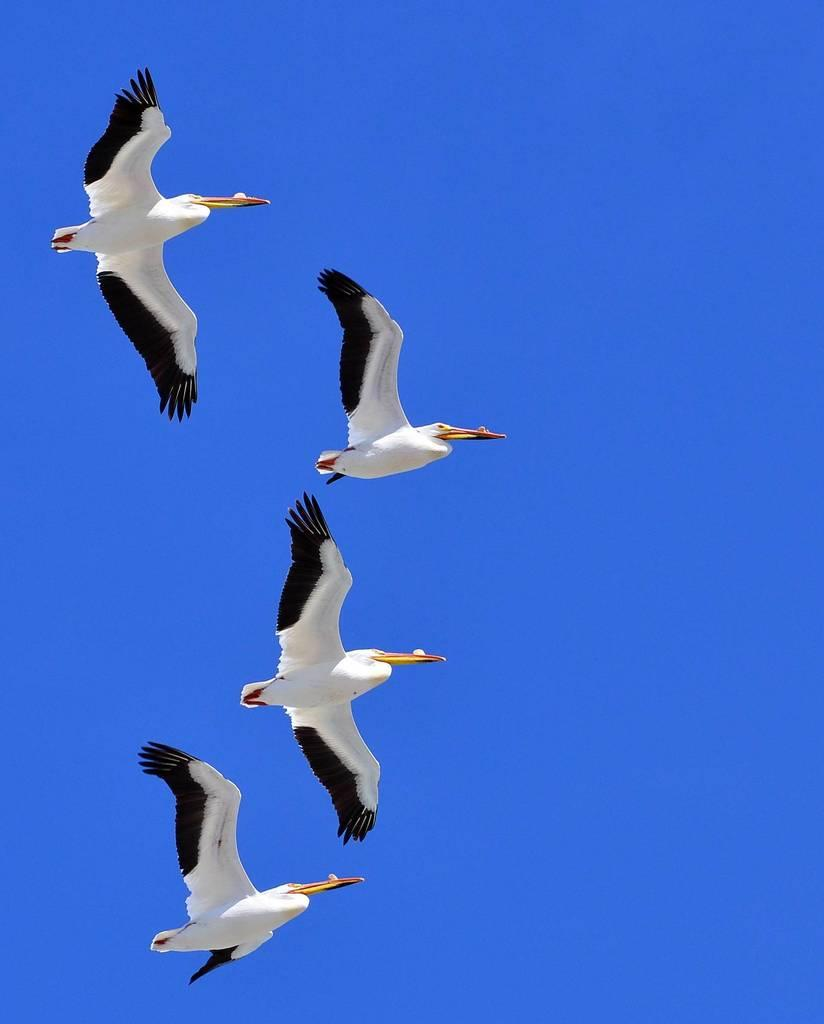How many birds can be seen in the image? There are four birds in the image. What are the birds doing in the image? The birds are flying in the air. What can be seen in the background of the image? The sky is visible in the background of the image. What type of wristwatch is visible on the geese in the image? There are no geese or wristwatches present in the image; it features four birds flying in the air. What type of school can be seen in the background of the image? There is no school visible in the image; it only features the sky in the background. 